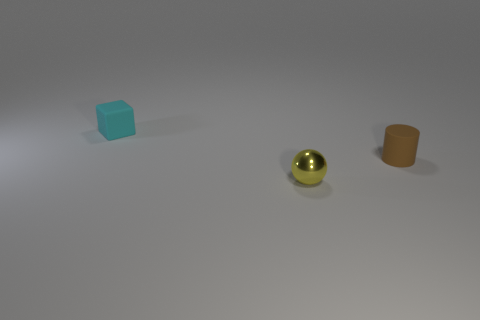Add 3 cyan rubber objects. How many objects exist? 6 Subtract all spheres. How many objects are left? 2 Subtract all green objects. Subtract all rubber cylinders. How many objects are left? 2 Add 3 cubes. How many cubes are left? 4 Add 2 tiny yellow things. How many tiny yellow things exist? 3 Subtract 0 purple balls. How many objects are left? 3 